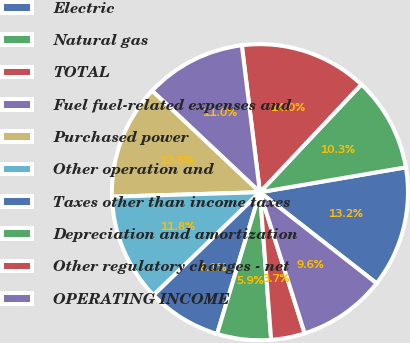Convert chart to OTSL. <chart><loc_0><loc_0><loc_500><loc_500><pie_chart><fcel>Electric<fcel>Natural gas<fcel>TOTAL<fcel>Fuel fuel-related expenses and<fcel>Purchased power<fcel>Other operation and<fcel>Taxes other than income taxes<fcel>Depreciation and amortization<fcel>Other regulatory charges - net<fcel>OPERATING INCOME<nl><fcel>13.24%<fcel>10.29%<fcel>13.97%<fcel>11.03%<fcel>12.5%<fcel>11.76%<fcel>8.09%<fcel>5.88%<fcel>3.68%<fcel>9.56%<nl></chart> 